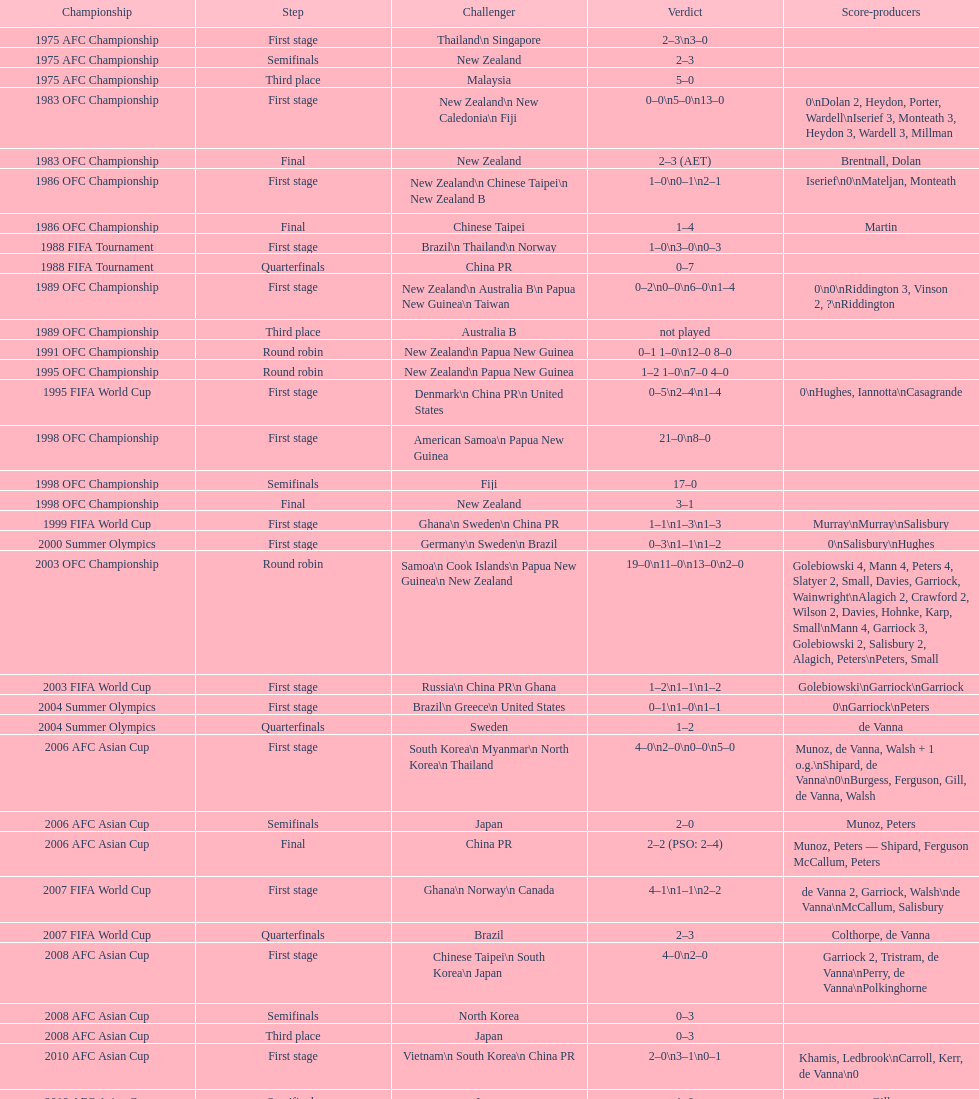What it the total number of countries in the first stage of the 2008 afc asian cup? 4. 